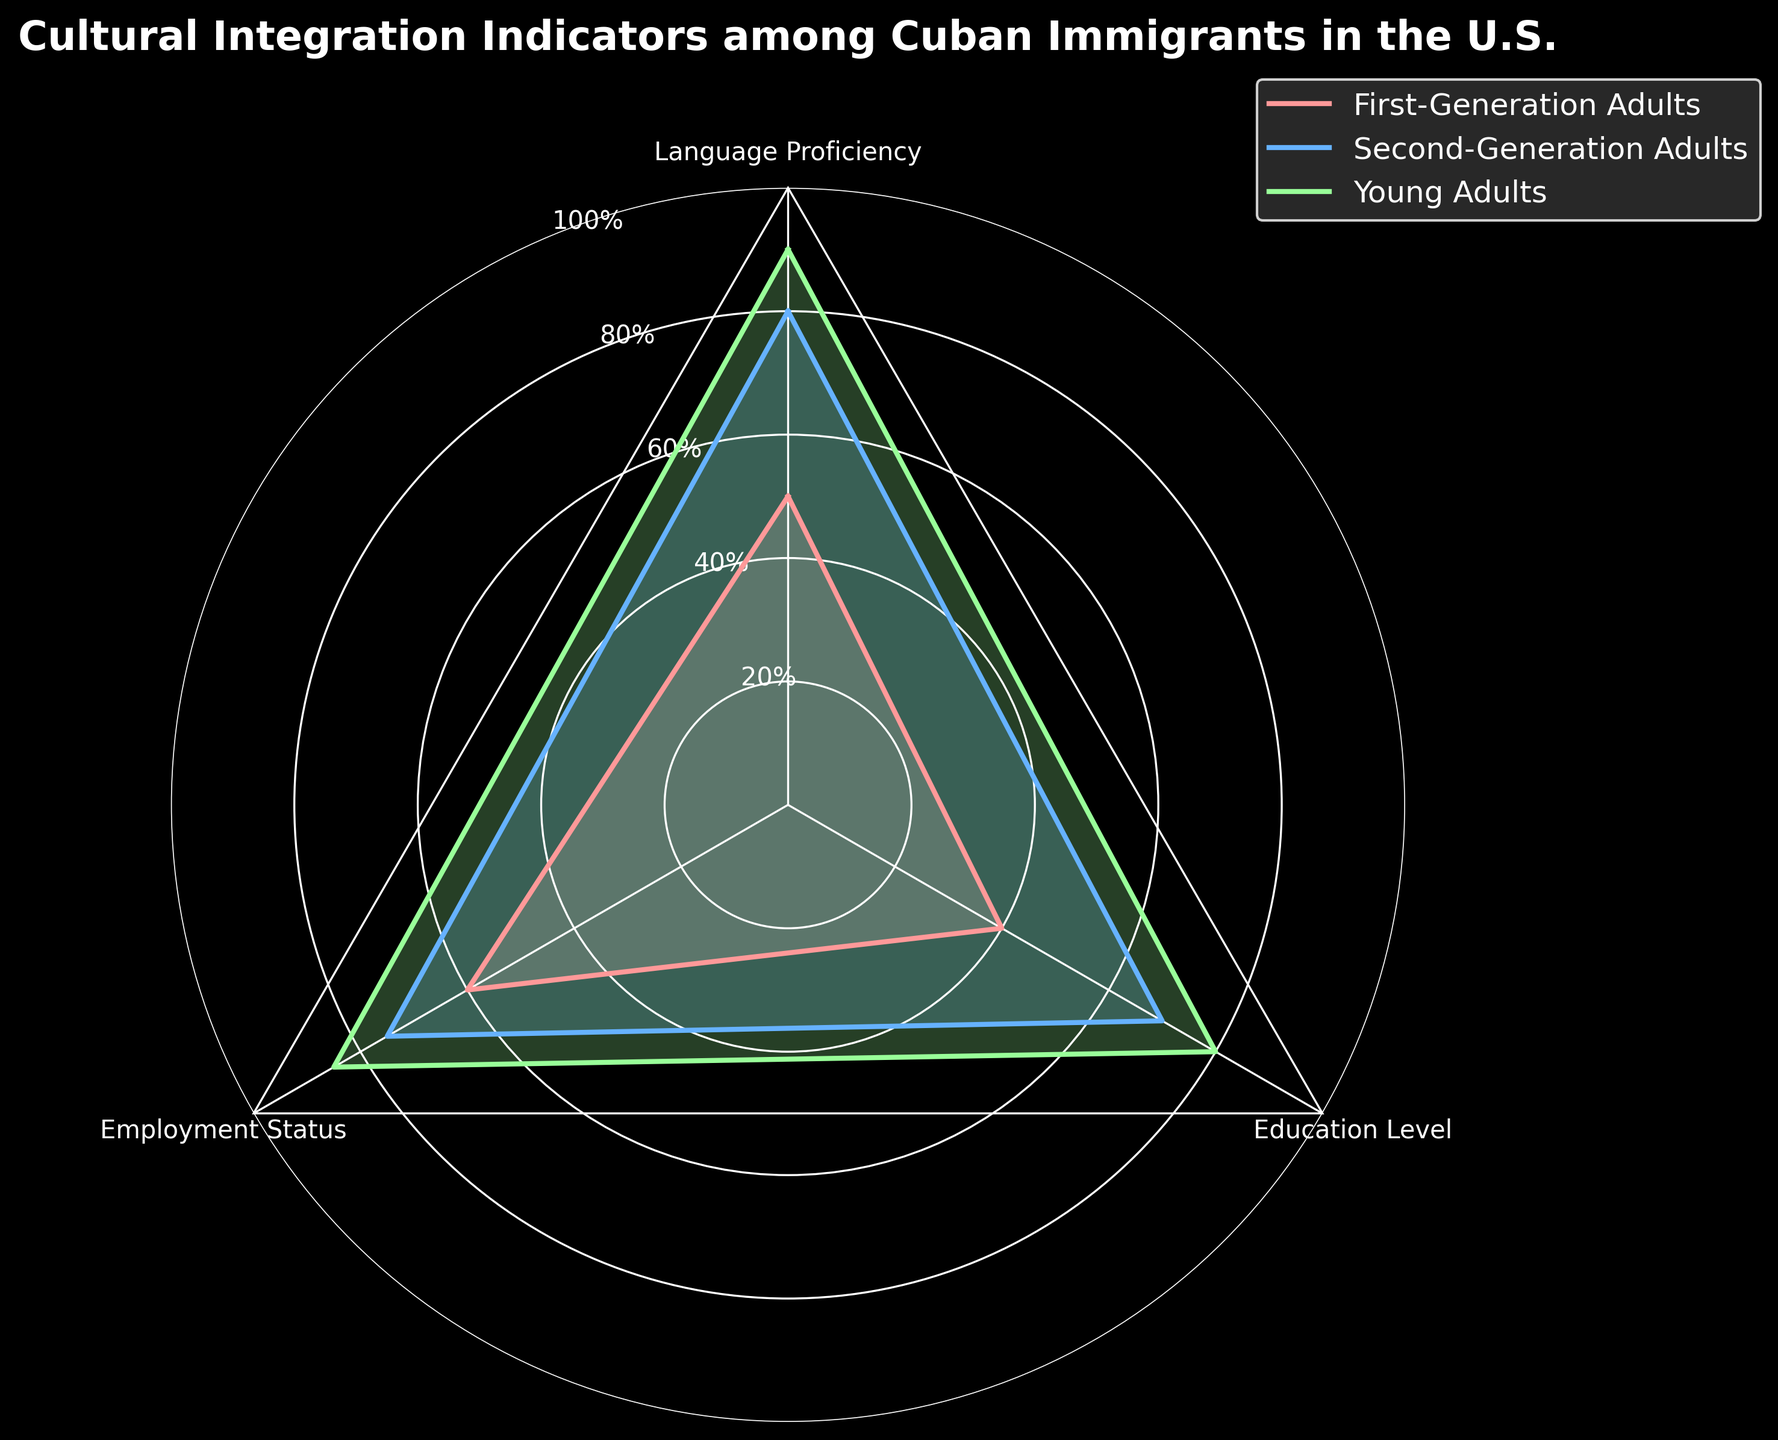What are the three categories visualized in the radar chart? The radar chart visualizes three categories: Language Proficiency, Employment Status, and Education Level. These are indicated as axis labels around the chart.
Answer: Language Proficiency, Employment Status, Education Level Which group shows the highest Language Proficiency? The group with the highest value shown in Language Proficiency is Young Adults, marked at 90 on the Language Proficiency axis.
Answer: Young Adults How do the Education Level scores compare between First-Generation Adults and Young Adults? By reading the values on the Education Level axis, First-Generation Adults have a score of 40, while Young Adults have a score of 80. Therefore, Young Adults have a higher Education Level by 40 points.
Answer: Young Adults have a higher score by 40 points What is the average score of Second-Generation Adults across all categories? The scores for Second-Generation Adults are 80 (Language Proficiency), 75 (Employment Status), and 70 (Education Level). Adding these gives 225. Dividing by the three categories gives 225 / 3 = 75.
Answer: 75 Which group has the lowest Employment Status and what is the value? The group with the lowest value in Employment Status is First-Generation Adults, marked at 60 on the Employment Status axis.
Answer: First-Generation Adults, 60 Is the Language Proficiency of Young Adults greater than, less than, or equal to the sum of the Education Level of First-Generation Adults and the Employment Status of Second-Generation Adults? The Language Proficiency of Young Adults is 90. The Education Level of First-Generation Adults is 40 and the Employment Status of Second-Generation Adults is 75. The sum of these two values is 40 + 75 = 115. 90 is less than 115.
Answer: Less than Which two groups have the most similar values across all three categories? Comparing the lines, Second-Generation Adults (80, 75, 70) and Young Adults (90, 85, 80) have the most similar values, with roughly 10-15 point differences in each category.
Answer: Second-Generation Adults and Young Adults What is the difference in Employment Status between Second-Generation Adults and Young Adults? The Employment Status for Second-Generation Adults is 75, while for Young Adults it is 85. The difference is 85 - 75 = 10.
Answer: 10 What is the overall trend seen in the radar chart as generations progress from First-Generation Adults to Young Adults? As generations progress from First-Generation Adults to Young Adults, there is a clear upward trend in all three categories: Language Proficiency, Employment Status, and Education Level increase steadily.
Answer: Increasing trend 